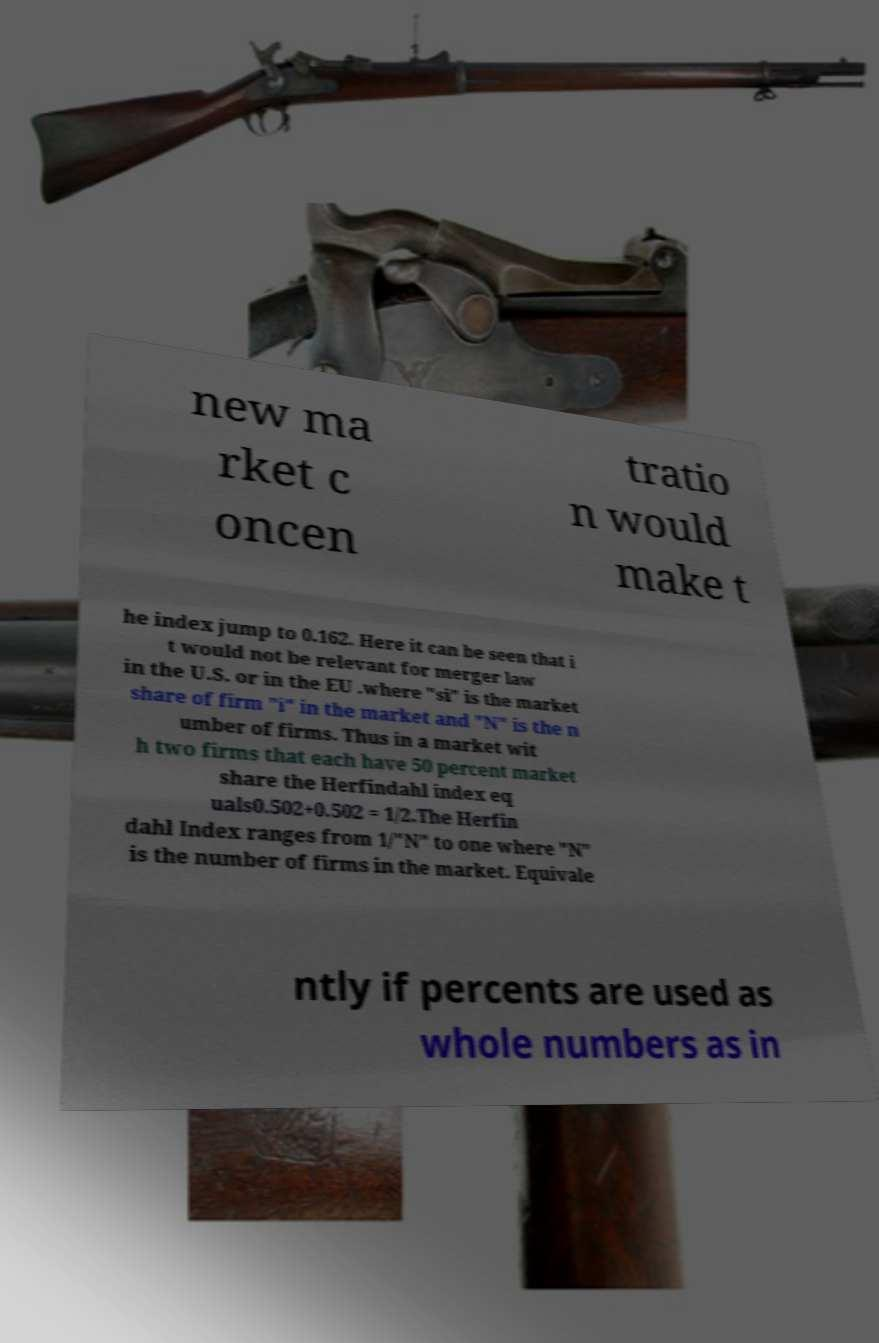Please read and relay the text visible in this image. What does it say? new ma rket c oncen tratio n would make t he index jump to 0.162. Here it can be seen that i t would not be relevant for merger law in the U.S. or in the EU .where "si" is the market share of firm "i" in the market and "N" is the n umber of firms. Thus in a market wit h two firms that each have 50 percent market share the Herfindahl index eq uals0.502+0.502 = 1/2.The Herfin dahl Index ranges from 1/"N" to one where "N" is the number of firms in the market. Equivale ntly if percents are used as whole numbers as in 